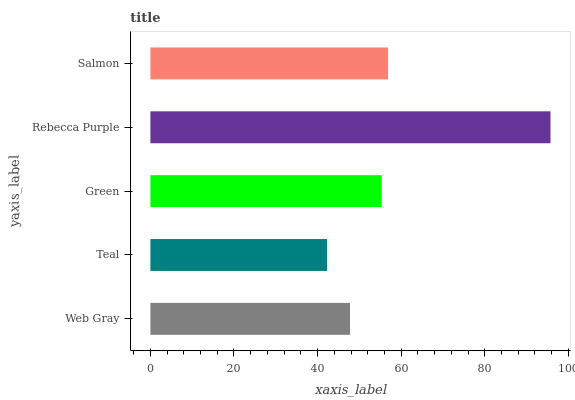Is Teal the minimum?
Answer yes or no. Yes. Is Rebecca Purple the maximum?
Answer yes or no. Yes. Is Green the minimum?
Answer yes or no. No. Is Green the maximum?
Answer yes or no. No. Is Green greater than Teal?
Answer yes or no. Yes. Is Teal less than Green?
Answer yes or no. Yes. Is Teal greater than Green?
Answer yes or no. No. Is Green less than Teal?
Answer yes or no. No. Is Green the high median?
Answer yes or no. Yes. Is Green the low median?
Answer yes or no. Yes. Is Salmon the high median?
Answer yes or no. No. Is Rebecca Purple the low median?
Answer yes or no. No. 